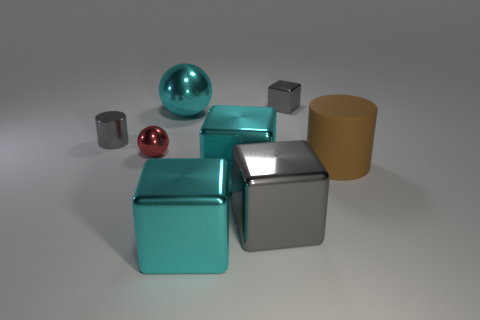Subtract all cyan blocks. How many were subtracted if there are1cyan blocks left? 1 Subtract all big blocks. How many blocks are left? 1 Add 1 gray metallic cylinders. How many objects exist? 9 Subtract all purple cubes. Subtract all green cylinders. How many cubes are left? 4 Add 2 balls. How many balls exist? 4 Subtract 0 red blocks. How many objects are left? 8 Subtract all balls. How many objects are left? 6 Subtract all tiny blue shiny objects. Subtract all tiny cylinders. How many objects are left? 7 Add 8 big balls. How many big balls are left? 9 